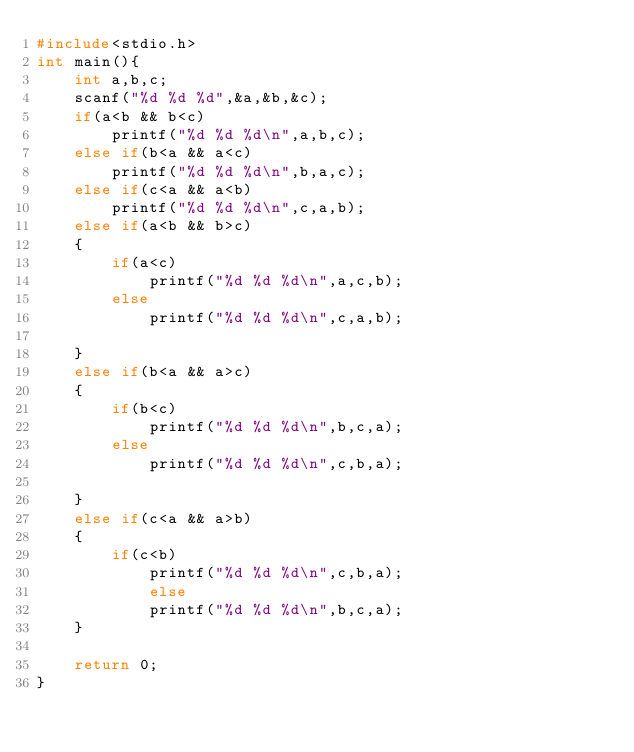<code> <loc_0><loc_0><loc_500><loc_500><_C_>#include<stdio.h>
int main(){
	int a,b,c;
	scanf("%d %d %d",&a,&b,&c);
	if(a<b && b<c)
        printf("%d %d %d\n",a,b,c);
    else if(b<a && a<c)
        printf("%d %d %d\n",b,a,c);
    else if(c<a && a<b)
        printf("%d %d %d\n",c,a,b);
    else if(a<b && b>c)
    {
        if(a<c)
            printf("%d %d %d\n",a,c,b);
        else
            printf("%d %d %d\n",c,a,b);

    }
    else if(b<a && a>c)
    {
        if(b<c)
            printf("%d %d %d\n",b,c,a);
        else
            printf("%d %d %d\n",c,b,a);

    }
    else if(c<a && a>b)
    {
        if(c<b)
            printf("%d %d %d\n",c,b,a);
            else
            printf("%d %d %d\n",b,c,a);
    }

    return 0;
}

</code> 